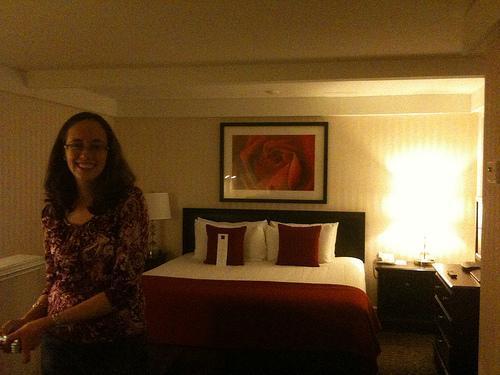How many people are in the room?
Give a very brief answer. 2. 